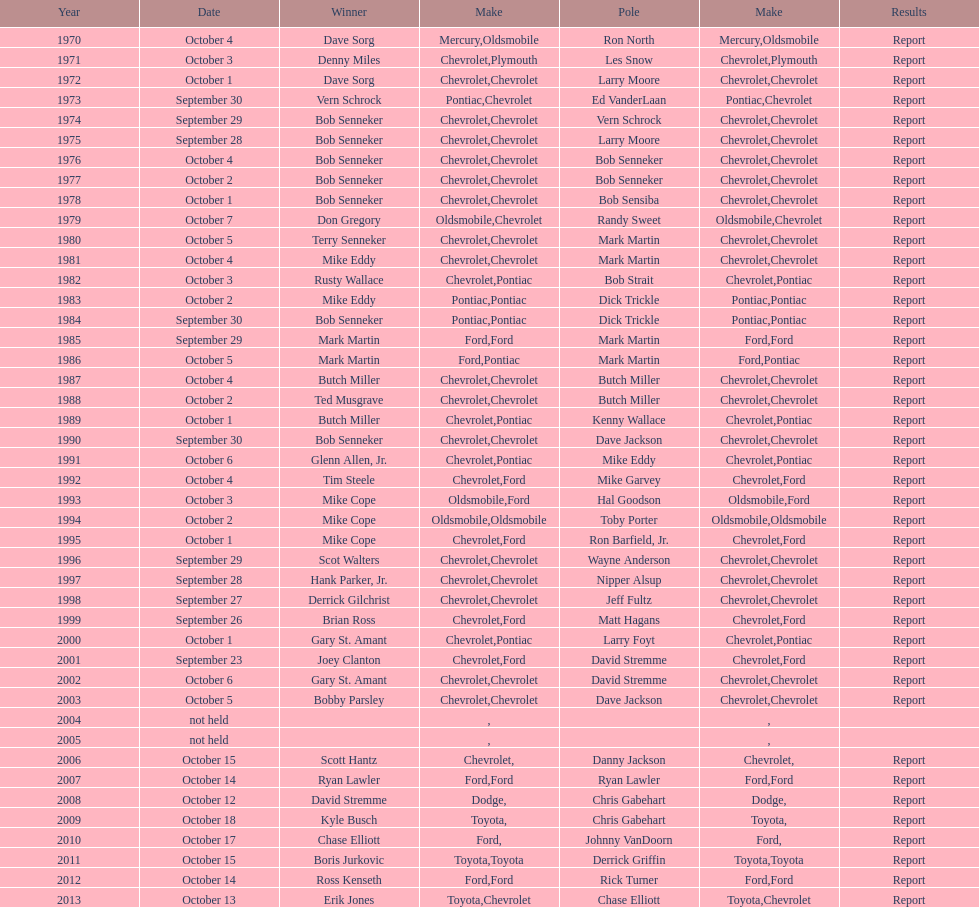Which make was used the least? Mercury. 